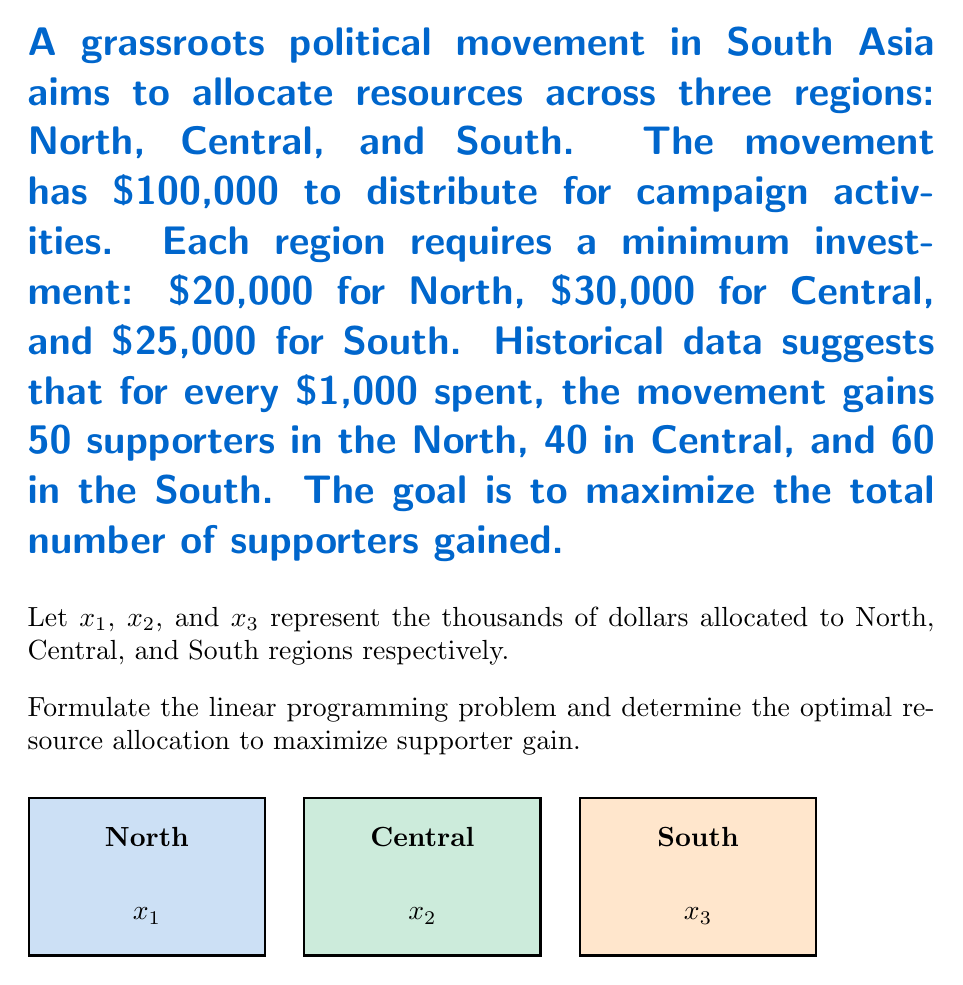Can you answer this question? To solve this linear programming problem, we'll follow these steps:

1) Formulate the objective function:
   Maximize $Z = 50x_1 + 40x_2 + 60x_3$

2) Identify the constraints:
   a) Budget constraint: $x_1 + x_2 + x_3 \leq 100$
   b) Minimum allocation constraints:
      $x_1 \geq 20$
      $x_2 \geq 30$
      $x_3 \geq 25$
   c) Non-negativity constraints: $x_1, x_2, x_3 \geq 0$

3) Set up the linear programming problem:
   Maximize $Z = 50x_1 + 40x_2 + 60x_3$
   Subject to:
   $x_1 + x_2 + x_3 \leq 100$
   $x_1 \geq 20$
   $x_2 \geq 30$
   $x_3 \geq 25$
   $x_1, x_2, x_3 \geq 0$

4) Solve using the simplex method or linear programming software.

5) The optimal solution is:
   $x_1 = 20$ (minimum allocation to North)
   $x_2 = 30$ (minimum allocation to Central)
   $x_3 = 50$ (remaining budget to South)

6) Verify the solution:
   Total allocation: $20 + 30 + 50 = 100$ (budget constraint satisfied)
   All minimum allocation constraints are met
   
7) Calculate the maximum number of supporters:
   $Z = 50(20) + 40(30) + 60(50) = 1000 + 1200 + 3000 = 5200$

Therefore, the optimal resource allocation is $20,000 to North, $30,000 to Central, and $50,000 to South, resulting in a maximum gain of 5,200 supporters.
Answer: North: $20,000; Central: $30,000; South: $50,000; Max supporters: 5,200 